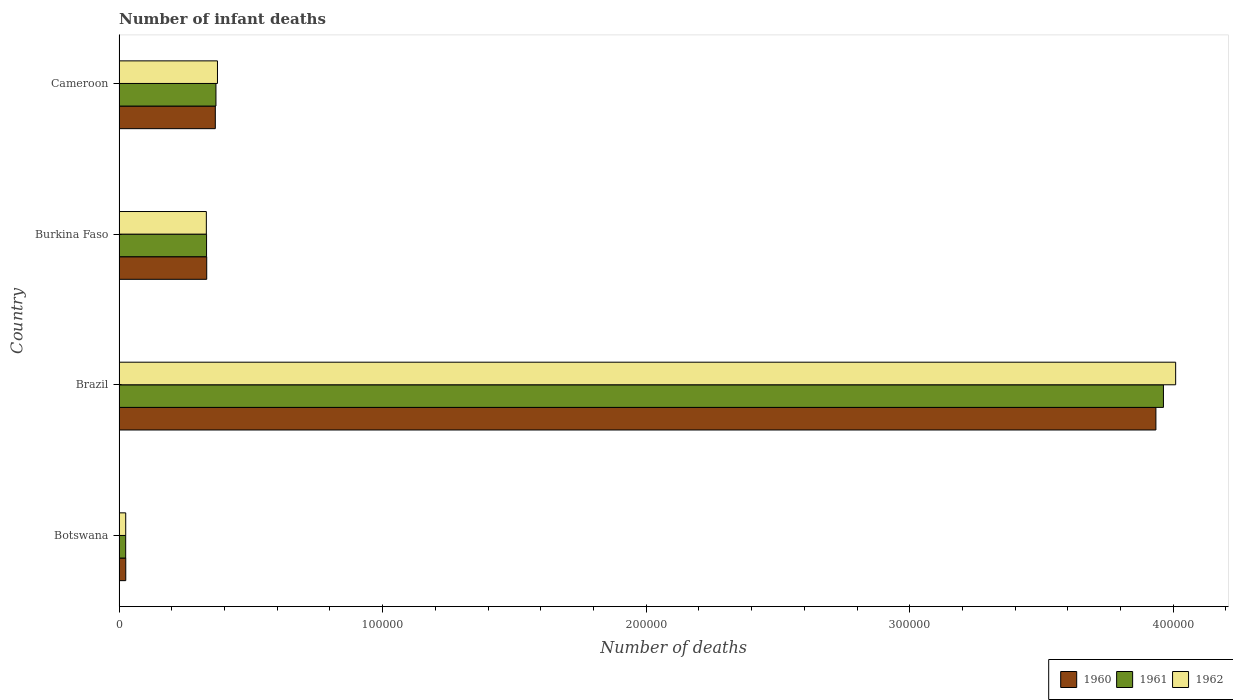How many different coloured bars are there?
Provide a succinct answer. 3. Are the number of bars per tick equal to the number of legend labels?
Your answer should be very brief. Yes. How many bars are there on the 2nd tick from the top?
Provide a short and direct response. 3. What is the label of the 2nd group of bars from the top?
Ensure brevity in your answer.  Burkina Faso. In how many cases, is the number of bars for a given country not equal to the number of legend labels?
Provide a short and direct response. 0. What is the number of infant deaths in 1961 in Brazil?
Your response must be concise. 3.96e+05. Across all countries, what is the maximum number of infant deaths in 1962?
Offer a terse response. 4.01e+05. Across all countries, what is the minimum number of infant deaths in 1961?
Keep it short and to the point. 2516. In which country was the number of infant deaths in 1961 minimum?
Ensure brevity in your answer.  Botswana. What is the total number of infant deaths in 1962 in the graph?
Your response must be concise. 4.74e+05. What is the difference between the number of infant deaths in 1961 in Brazil and that in Cameroon?
Make the answer very short. 3.60e+05. What is the difference between the number of infant deaths in 1960 in Cameroon and the number of infant deaths in 1961 in Botswana?
Provide a short and direct response. 3.40e+04. What is the average number of infant deaths in 1960 per country?
Provide a succinct answer. 1.16e+05. What is the difference between the number of infant deaths in 1960 and number of infant deaths in 1961 in Cameroon?
Your answer should be compact. -238. What is the ratio of the number of infant deaths in 1962 in Brazil to that in Cameroon?
Keep it short and to the point. 10.74. Is the number of infant deaths in 1961 in Botswana less than that in Brazil?
Offer a terse response. Yes. What is the difference between the highest and the second highest number of infant deaths in 1962?
Your response must be concise. 3.64e+05. What is the difference between the highest and the lowest number of infant deaths in 1961?
Offer a very short reply. 3.94e+05. In how many countries, is the number of infant deaths in 1961 greater than the average number of infant deaths in 1961 taken over all countries?
Offer a terse response. 1. Is the sum of the number of infant deaths in 1961 in Botswana and Cameroon greater than the maximum number of infant deaths in 1962 across all countries?
Provide a succinct answer. No. What does the 2nd bar from the top in Botswana represents?
Offer a very short reply. 1961. Is it the case that in every country, the sum of the number of infant deaths in 1962 and number of infant deaths in 1961 is greater than the number of infant deaths in 1960?
Provide a short and direct response. Yes. How many bars are there?
Give a very brief answer. 12. What is the difference between two consecutive major ticks on the X-axis?
Your answer should be very brief. 1.00e+05. Are the values on the major ticks of X-axis written in scientific E-notation?
Provide a short and direct response. No. Where does the legend appear in the graph?
Ensure brevity in your answer.  Bottom right. How are the legend labels stacked?
Your answer should be very brief. Horizontal. What is the title of the graph?
Give a very brief answer. Number of infant deaths. What is the label or title of the X-axis?
Your answer should be very brief. Number of deaths. What is the label or title of the Y-axis?
Provide a succinct answer. Country. What is the Number of deaths in 1960 in Botswana?
Your response must be concise. 2546. What is the Number of deaths in 1961 in Botswana?
Offer a very short reply. 2516. What is the Number of deaths in 1962 in Botswana?
Ensure brevity in your answer.  2530. What is the Number of deaths of 1960 in Brazil?
Provide a short and direct response. 3.93e+05. What is the Number of deaths in 1961 in Brazil?
Provide a short and direct response. 3.96e+05. What is the Number of deaths of 1962 in Brazil?
Your answer should be very brief. 4.01e+05. What is the Number of deaths of 1960 in Burkina Faso?
Your answer should be compact. 3.33e+04. What is the Number of deaths in 1961 in Burkina Faso?
Your answer should be compact. 3.32e+04. What is the Number of deaths of 1962 in Burkina Faso?
Offer a terse response. 3.31e+04. What is the Number of deaths in 1960 in Cameroon?
Your answer should be compact. 3.65e+04. What is the Number of deaths in 1961 in Cameroon?
Provide a short and direct response. 3.68e+04. What is the Number of deaths in 1962 in Cameroon?
Provide a succinct answer. 3.73e+04. Across all countries, what is the maximum Number of deaths of 1960?
Give a very brief answer. 3.93e+05. Across all countries, what is the maximum Number of deaths in 1961?
Your answer should be very brief. 3.96e+05. Across all countries, what is the maximum Number of deaths of 1962?
Your response must be concise. 4.01e+05. Across all countries, what is the minimum Number of deaths in 1960?
Ensure brevity in your answer.  2546. Across all countries, what is the minimum Number of deaths of 1961?
Your answer should be very brief. 2516. Across all countries, what is the minimum Number of deaths of 1962?
Your answer should be compact. 2530. What is the total Number of deaths in 1960 in the graph?
Your response must be concise. 4.66e+05. What is the total Number of deaths of 1961 in the graph?
Offer a terse response. 4.69e+05. What is the total Number of deaths of 1962 in the graph?
Give a very brief answer. 4.74e+05. What is the difference between the Number of deaths of 1960 in Botswana and that in Brazil?
Give a very brief answer. -3.91e+05. What is the difference between the Number of deaths in 1961 in Botswana and that in Brazil?
Offer a terse response. -3.94e+05. What is the difference between the Number of deaths in 1962 in Botswana and that in Brazil?
Your answer should be compact. -3.98e+05. What is the difference between the Number of deaths in 1960 in Botswana and that in Burkina Faso?
Your answer should be compact. -3.07e+04. What is the difference between the Number of deaths of 1961 in Botswana and that in Burkina Faso?
Ensure brevity in your answer.  -3.07e+04. What is the difference between the Number of deaths in 1962 in Botswana and that in Burkina Faso?
Your answer should be very brief. -3.06e+04. What is the difference between the Number of deaths of 1960 in Botswana and that in Cameroon?
Provide a short and direct response. -3.40e+04. What is the difference between the Number of deaths of 1961 in Botswana and that in Cameroon?
Provide a succinct answer. -3.42e+04. What is the difference between the Number of deaths in 1962 in Botswana and that in Cameroon?
Make the answer very short. -3.48e+04. What is the difference between the Number of deaths of 1960 in Brazil and that in Burkina Faso?
Your answer should be compact. 3.60e+05. What is the difference between the Number of deaths in 1961 in Brazil and that in Burkina Faso?
Offer a terse response. 3.63e+05. What is the difference between the Number of deaths of 1962 in Brazil and that in Burkina Faso?
Your answer should be compact. 3.68e+05. What is the difference between the Number of deaths in 1960 in Brazil and that in Cameroon?
Keep it short and to the point. 3.57e+05. What is the difference between the Number of deaths in 1961 in Brazil and that in Cameroon?
Provide a short and direct response. 3.60e+05. What is the difference between the Number of deaths in 1962 in Brazil and that in Cameroon?
Ensure brevity in your answer.  3.64e+05. What is the difference between the Number of deaths of 1960 in Burkina Faso and that in Cameroon?
Make the answer very short. -3262. What is the difference between the Number of deaths in 1961 in Burkina Faso and that in Cameroon?
Offer a very short reply. -3562. What is the difference between the Number of deaths of 1962 in Burkina Faso and that in Cameroon?
Offer a terse response. -4216. What is the difference between the Number of deaths of 1960 in Botswana and the Number of deaths of 1961 in Brazil?
Your answer should be very brief. -3.94e+05. What is the difference between the Number of deaths of 1960 in Botswana and the Number of deaths of 1962 in Brazil?
Provide a short and direct response. -3.98e+05. What is the difference between the Number of deaths of 1961 in Botswana and the Number of deaths of 1962 in Brazil?
Ensure brevity in your answer.  -3.98e+05. What is the difference between the Number of deaths in 1960 in Botswana and the Number of deaths in 1961 in Burkina Faso?
Offer a very short reply. -3.07e+04. What is the difference between the Number of deaths in 1960 in Botswana and the Number of deaths in 1962 in Burkina Faso?
Offer a very short reply. -3.06e+04. What is the difference between the Number of deaths in 1961 in Botswana and the Number of deaths in 1962 in Burkina Faso?
Your answer should be compact. -3.06e+04. What is the difference between the Number of deaths in 1960 in Botswana and the Number of deaths in 1961 in Cameroon?
Make the answer very short. -3.42e+04. What is the difference between the Number of deaths of 1960 in Botswana and the Number of deaths of 1962 in Cameroon?
Offer a very short reply. -3.48e+04. What is the difference between the Number of deaths of 1961 in Botswana and the Number of deaths of 1962 in Cameroon?
Make the answer very short. -3.48e+04. What is the difference between the Number of deaths of 1960 in Brazil and the Number of deaths of 1961 in Burkina Faso?
Offer a terse response. 3.60e+05. What is the difference between the Number of deaths in 1960 in Brazil and the Number of deaths in 1962 in Burkina Faso?
Make the answer very short. 3.60e+05. What is the difference between the Number of deaths of 1961 in Brazil and the Number of deaths of 1962 in Burkina Faso?
Your response must be concise. 3.63e+05. What is the difference between the Number of deaths of 1960 in Brazil and the Number of deaths of 1961 in Cameroon?
Offer a terse response. 3.57e+05. What is the difference between the Number of deaths of 1960 in Brazil and the Number of deaths of 1962 in Cameroon?
Provide a succinct answer. 3.56e+05. What is the difference between the Number of deaths of 1961 in Brazil and the Number of deaths of 1962 in Cameroon?
Provide a succinct answer. 3.59e+05. What is the difference between the Number of deaths of 1960 in Burkina Faso and the Number of deaths of 1961 in Cameroon?
Your answer should be very brief. -3500. What is the difference between the Number of deaths in 1960 in Burkina Faso and the Number of deaths in 1962 in Cameroon?
Ensure brevity in your answer.  -4075. What is the difference between the Number of deaths in 1961 in Burkina Faso and the Number of deaths in 1962 in Cameroon?
Your answer should be very brief. -4137. What is the average Number of deaths of 1960 per country?
Make the answer very short. 1.16e+05. What is the average Number of deaths in 1961 per country?
Provide a succinct answer. 1.17e+05. What is the average Number of deaths in 1962 per country?
Offer a terse response. 1.18e+05. What is the difference between the Number of deaths of 1960 and Number of deaths of 1962 in Botswana?
Your answer should be very brief. 16. What is the difference between the Number of deaths in 1960 and Number of deaths in 1961 in Brazil?
Offer a very short reply. -2856. What is the difference between the Number of deaths of 1960 and Number of deaths of 1962 in Brazil?
Ensure brevity in your answer.  -7497. What is the difference between the Number of deaths in 1961 and Number of deaths in 1962 in Brazil?
Ensure brevity in your answer.  -4641. What is the difference between the Number of deaths in 1960 and Number of deaths in 1961 in Burkina Faso?
Give a very brief answer. 62. What is the difference between the Number of deaths in 1960 and Number of deaths in 1962 in Burkina Faso?
Your response must be concise. 141. What is the difference between the Number of deaths of 1961 and Number of deaths of 1962 in Burkina Faso?
Your answer should be very brief. 79. What is the difference between the Number of deaths in 1960 and Number of deaths in 1961 in Cameroon?
Provide a succinct answer. -238. What is the difference between the Number of deaths of 1960 and Number of deaths of 1962 in Cameroon?
Offer a terse response. -813. What is the difference between the Number of deaths of 1961 and Number of deaths of 1962 in Cameroon?
Provide a short and direct response. -575. What is the ratio of the Number of deaths in 1960 in Botswana to that in Brazil?
Provide a short and direct response. 0.01. What is the ratio of the Number of deaths in 1961 in Botswana to that in Brazil?
Your answer should be very brief. 0.01. What is the ratio of the Number of deaths of 1962 in Botswana to that in Brazil?
Keep it short and to the point. 0.01. What is the ratio of the Number of deaths in 1960 in Botswana to that in Burkina Faso?
Your answer should be compact. 0.08. What is the ratio of the Number of deaths in 1961 in Botswana to that in Burkina Faso?
Your response must be concise. 0.08. What is the ratio of the Number of deaths in 1962 in Botswana to that in Burkina Faso?
Your response must be concise. 0.08. What is the ratio of the Number of deaths of 1960 in Botswana to that in Cameroon?
Your answer should be very brief. 0.07. What is the ratio of the Number of deaths of 1961 in Botswana to that in Cameroon?
Your response must be concise. 0.07. What is the ratio of the Number of deaths of 1962 in Botswana to that in Cameroon?
Give a very brief answer. 0.07. What is the ratio of the Number of deaths of 1960 in Brazil to that in Burkina Faso?
Provide a succinct answer. 11.83. What is the ratio of the Number of deaths in 1961 in Brazil to that in Burkina Faso?
Give a very brief answer. 11.93. What is the ratio of the Number of deaths in 1962 in Brazil to that in Burkina Faso?
Your answer should be compact. 12.1. What is the ratio of the Number of deaths of 1960 in Brazil to that in Cameroon?
Give a very brief answer. 10.77. What is the ratio of the Number of deaths in 1961 in Brazil to that in Cameroon?
Keep it short and to the point. 10.78. What is the ratio of the Number of deaths in 1962 in Brazil to that in Cameroon?
Your answer should be compact. 10.74. What is the ratio of the Number of deaths in 1960 in Burkina Faso to that in Cameroon?
Offer a very short reply. 0.91. What is the ratio of the Number of deaths in 1961 in Burkina Faso to that in Cameroon?
Your response must be concise. 0.9. What is the ratio of the Number of deaths of 1962 in Burkina Faso to that in Cameroon?
Make the answer very short. 0.89. What is the difference between the highest and the second highest Number of deaths in 1960?
Make the answer very short. 3.57e+05. What is the difference between the highest and the second highest Number of deaths in 1961?
Offer a terse response. 3.60e+05. What is the difference between the highest and the second highest Number of deaths in 1962?
Offer a terse response. 3.64e+05. What is the difference between the highest and the lowest Number of deaths in 1960?
Ensure brevity in your answer.  3.91e+05. What is the difference between the highest and the lowest Number of deaths of 1961?
Your answer should be compact. 3.94e+05. What is the difference between the highest and the lowest Number of deaths of 1962?
Keep it short and to the point. 3.98e+05. 